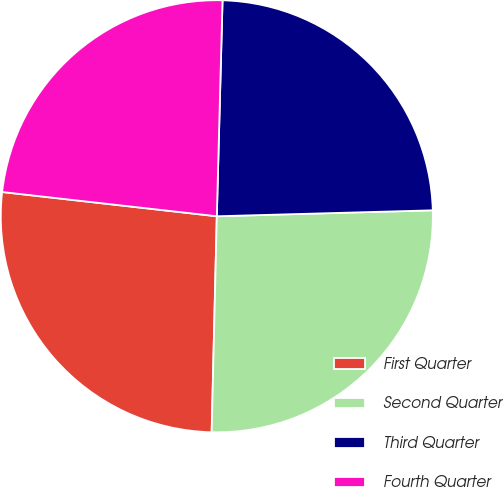<chart> <loc_0><loc_0><loc_500><loc_500><pie_chart><fcel>First Quarter<fcel>Second Quarter<fcel>Third Quarter<fcel>Fourth Quarter<nl><fcel>26.41%<fcel>25.82%<fcel>24.14%<fcel>23.63%<nl></chart> 